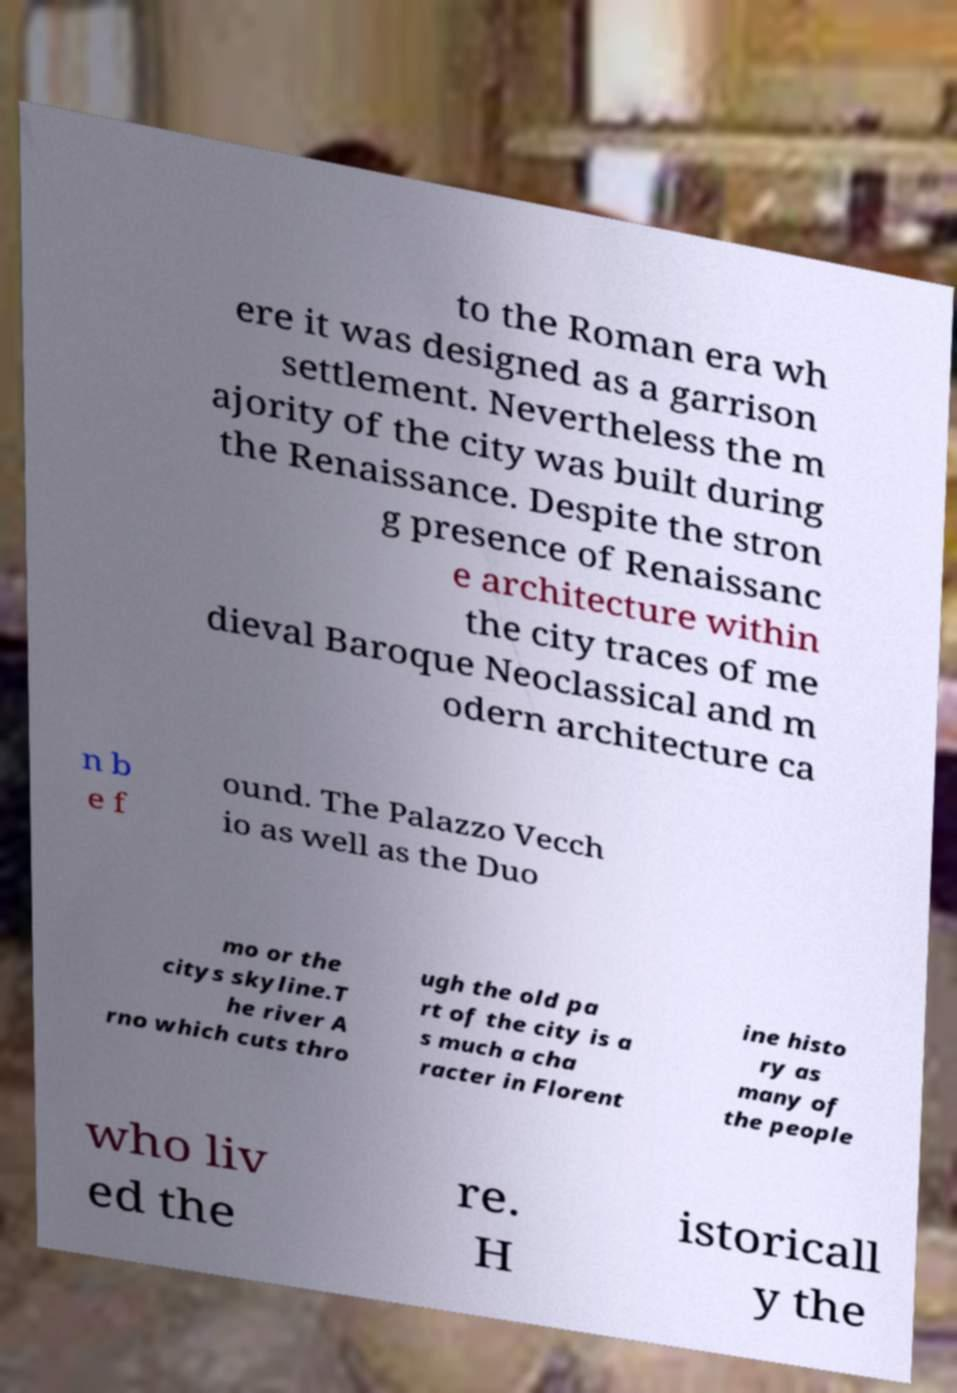What messages or text are displayed in this image? I need them in a readable, typed format. to the Roman era wh ere it was designed as a garrison settlement. Nevertheless the m ajority of the city was built during the Renaissance. Despite the stron g presence of Renaissanc e architecture within the city traces of me dieval Baroque Neoclassical and m odern architecture ca n b e f ound. The Palazzo Vecch io as well as the Duo mo or the citys skyline.T he river A rno which cuts thro ugh the old pa rt of the city is a s much a cha racter in Florent ine histo ry as many of the people who liv ed the re. H istoricall y the 